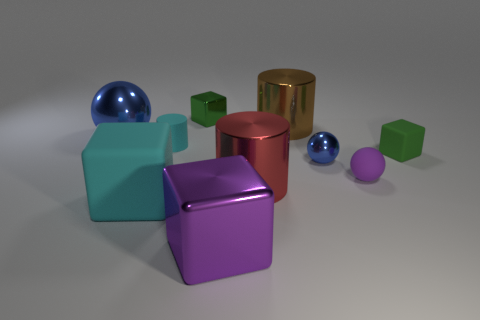Does the small metal sphere have the same color as the large ball?
Provide a short and direct response. Yes. There is a thing that is the same color as the small shiny cube; what size is it?
Your answer should be very brief. Small. What color is the sphere that is the same size as the purple matte thing?
Your answer should be very brief. Blue. Is there a blue metallic sphere left of the tiny green thing right of the green shiny thing?
Offer a terse response. Yes. What is the material of the small green thing that is right of the large brown shiny cylinder?
Offer a terse response. Rubber. Is the blue ball on the left side of the large cyan thing made of the same material as the large purple thing that is in front of the small matte sphere?
Provide a short and direct response. Yes. Are there the same number of cyan cubes on the right side of the small purple thing and small purple things that are in front of the big metallic cube?
Provide a succinct answer. Yes. What number of tiny purple balls are the same material as the big purple block?
Provide a succinct answer. 0. There is a object that is the same color as the big sphere; what is its shape?
Your answer should be compact. Sphere. There is a purple thing left of the shiny sphere on the right side of the big brown shiny object; what is its size?
Your answer should be compact. Large. 